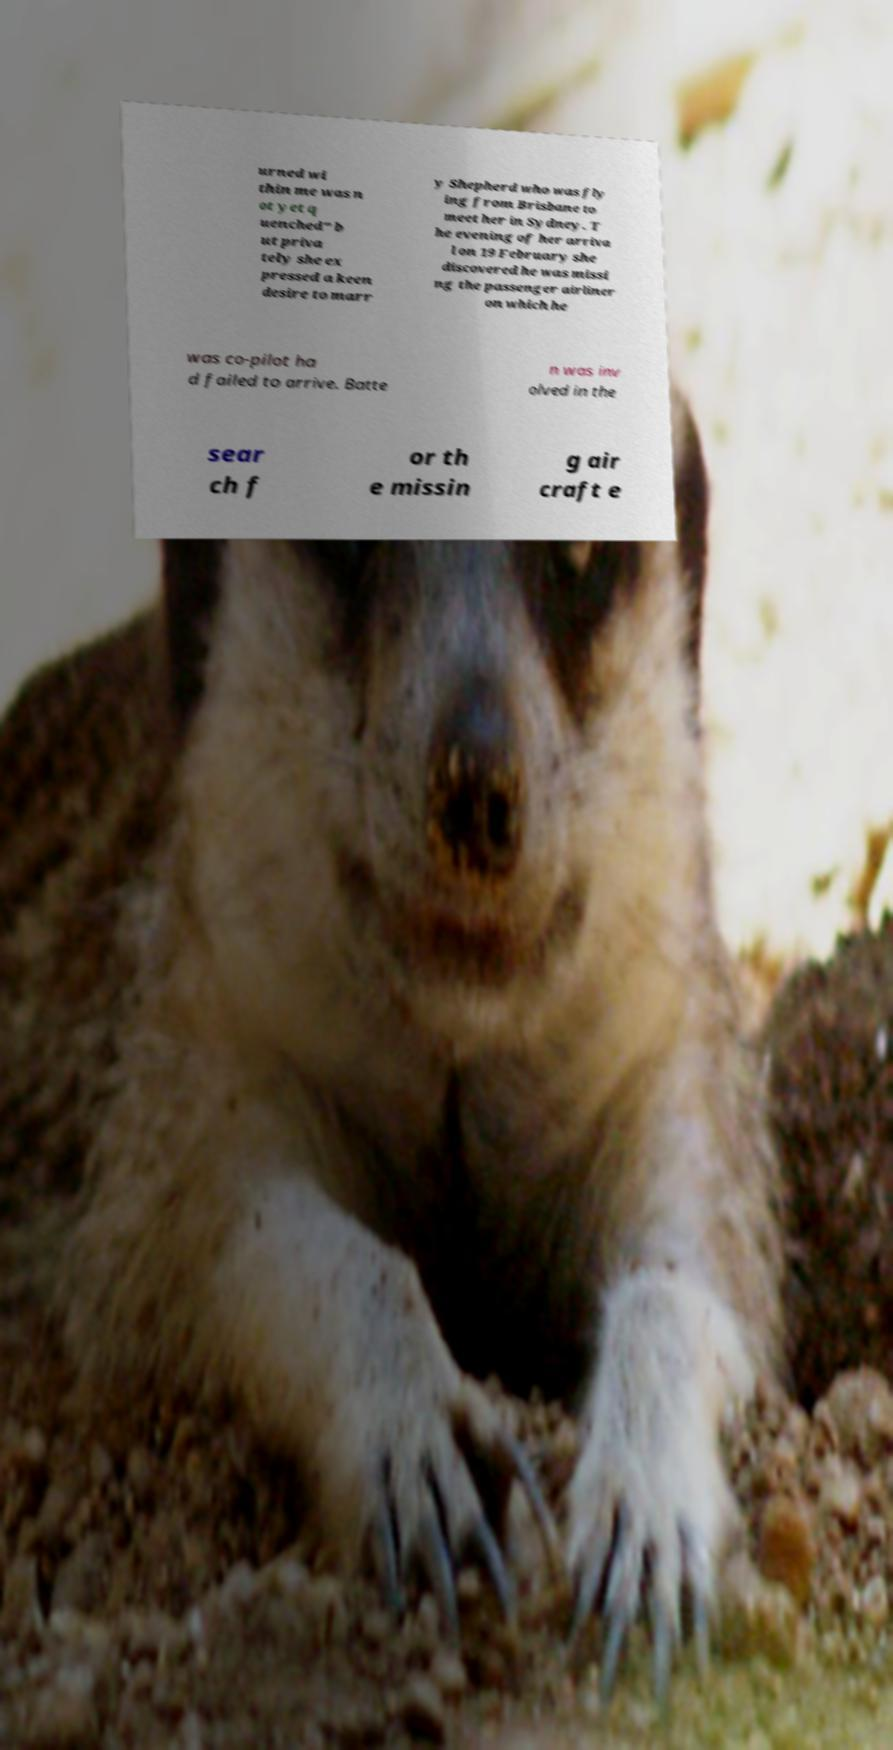What messages or text are displayed in this image? I need them in a readable, typed format. urned wi thin me was n ot yet q uenched" b ut priva tely she ex pressed a keen desire to marr y Shepherd who was fly ing from Brisbane to meet her in Sydney. T he evening of her arriva l on 19 February she discovered he was missi ng the passenger airliner on which he was co-pilot ha d failed to arrive. Batte n was inv olved in the sear ch f or th e missin g air craft e 